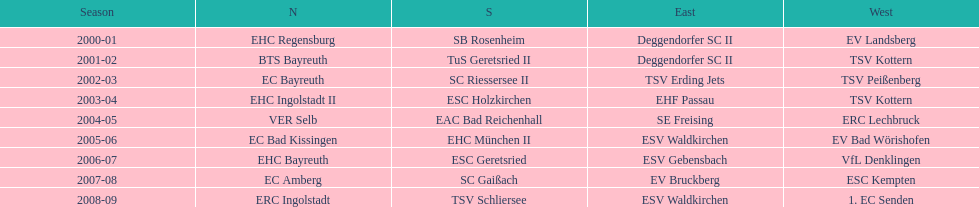What is the number of times deggendorfer sc ii is on the list? 2. 